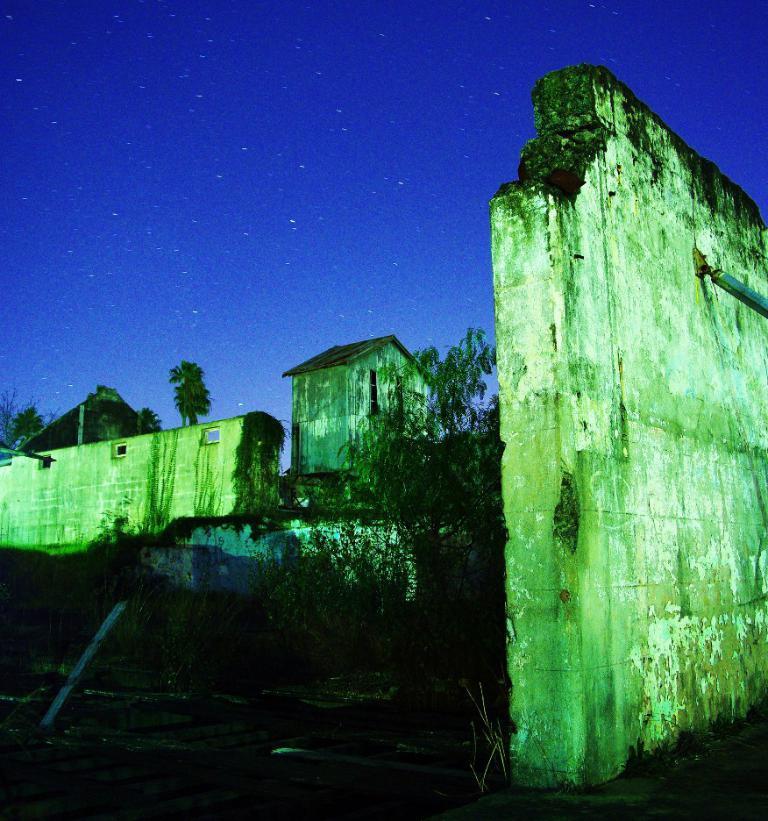Please provide a concise description of this image. In this image we can see walls, trees, objects, small shed and stars in the sky. 